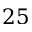Convert formula to latex. <formula><loc_0><loc_0><loc_500><loc_500>2 5</formula> 